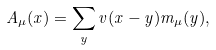<formula> <loc_0><loc_0><loc_500><loc_500>A _ { \mu } ( x ) = \sum _ { y } v ( x - y ) m _ { \mu } ( y ) ,</formula> 